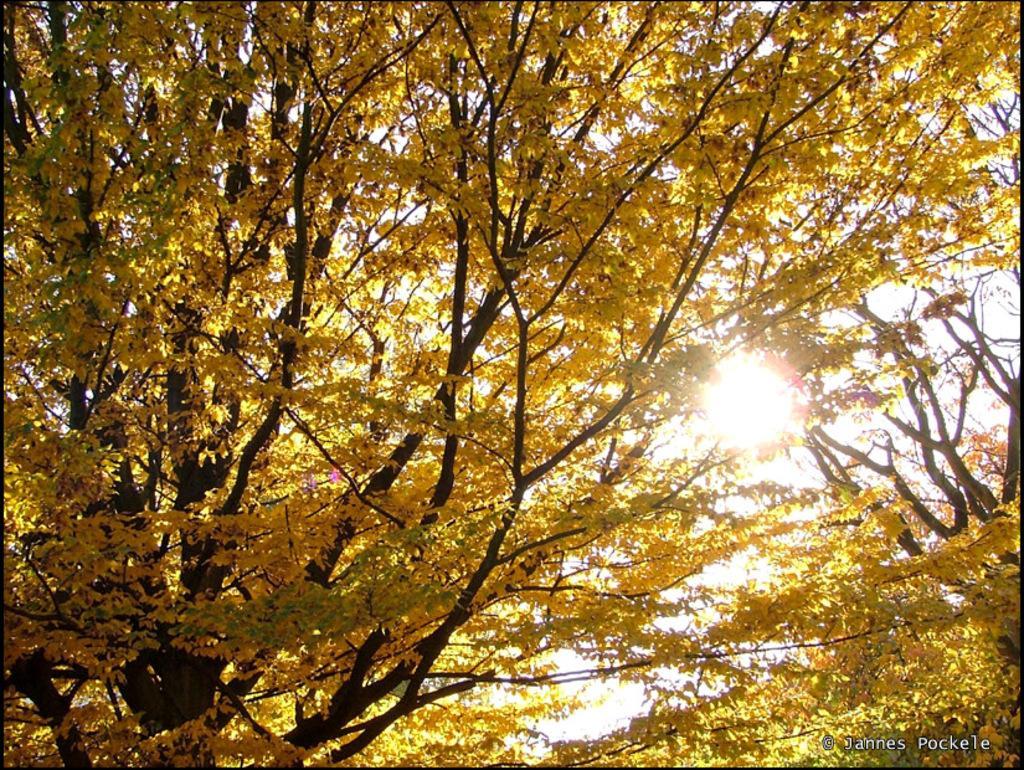Could you give a brief overview of what you see in this image? In this image, we can see some trees. 